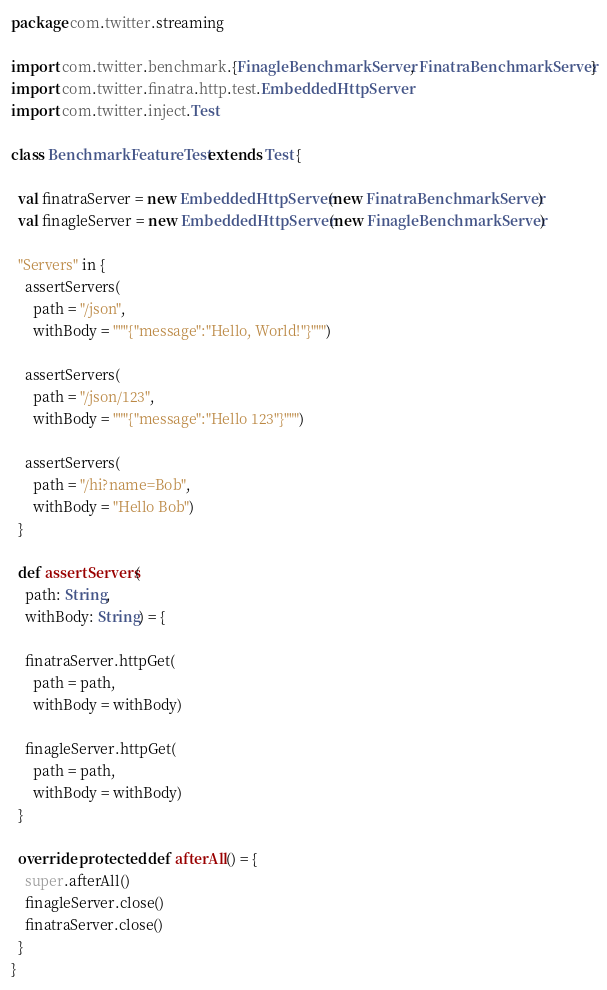<code> <loc_0><loc_0><loc_500><loc_500><_Scala_>package com.twitter.streaming

import com.twitter.benchmark.{FinagleBenchmarkServer, FinatraBenchmarkServer}
import com.twitter.finatra.http.test.EmbeddedHttpServer
import com.twitter.inject.Test

class BenchmarkFeatureTest extends Test {

  val finatraServer = new EmbeddedHttpServer(new FinatraBenchmarkServer)
  val finagleServer = new EmbeddedHttpServer(new FinagleBenchmarkServer)

  "Servers" in {
    assertServers(
      path = "/json",
      withBody = """{"message":"Hello, World!"}""")

    assertServers(
      path = "/json/123",
      withBody = """{"message":"Hello 123"}""")

    assertServers(
      path = "/hi?name=Bob",
      withBody = "Hello Bob")
  }

  def assertServers(
    path: String,
    withBody: String) = {

    finatraServer.httpGet(
      path = path,
      withBody = withBody)

    finagleServer.httpGet(
      path = path,
      withBody = withBody)
  }

  override protected def afterAll() = {
    super.afterAll()
    finagleServer.close()
    finatraServer.close()
  }
}
</code> 